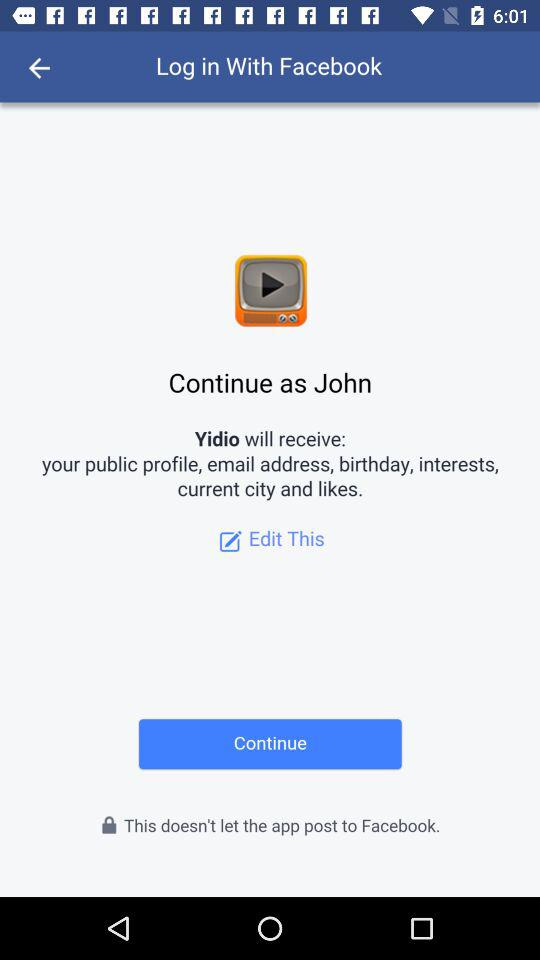What application is asking for permission? The application that is asking for permission is "Yidio". 